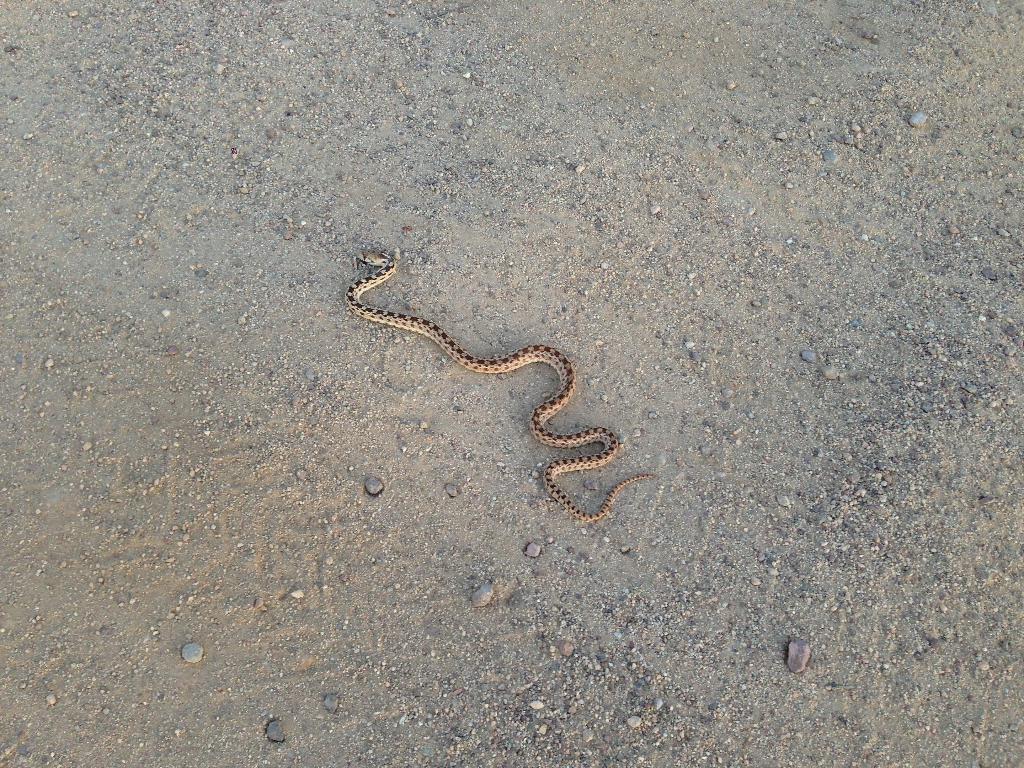In one or two sentences, can you explain what this image depicts? In this picture there is a snake on the sand. At the bottom there is mud and there are stones. 